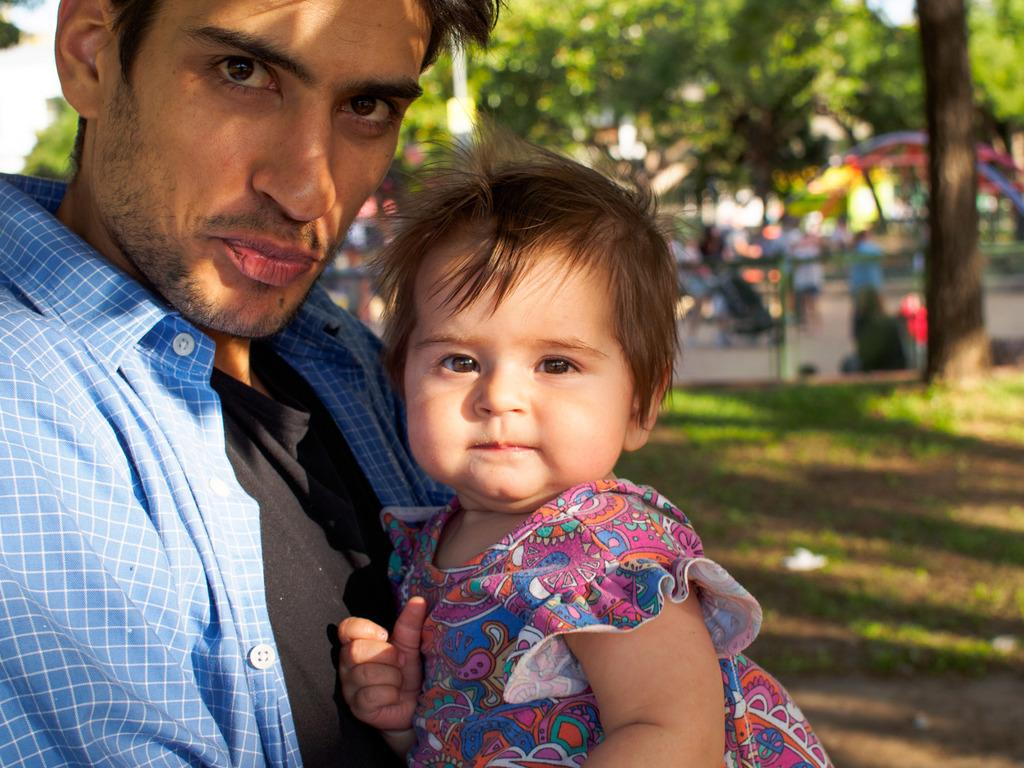What is the main subject in the foreground of the image? There is a man in the foreground of the image. What is the man doing in the image? The man is carrying a girl. What type of natural environment is visible in the background of the image? There is grass and a tree in the background of the image. Can you describe the objects in the background that are not clearly visible? Unfortunately, the remaining objects in the background are unclear. What type of sleet can be seen falling from the tree in the image? There is no sleet present in the image; it is a grassy area with a tree in the background. How many men are visible in the image? There is only one man visible in the image, as he is carrying a girl. 